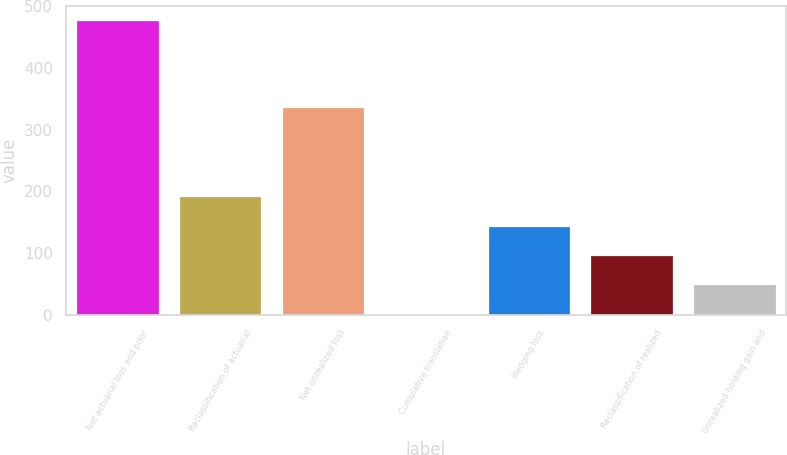Convert chart to OTSL. <chart><loc_0><loc_0><loc_500><loc_500><bar_chart><fcel>Net actuarial loss and prior<fcel>Reclassification of actuarial<fcel>Net unrealized loss<fcel>Cumulative translation<fcel>Hedging loss<fcel>Reclassification of realized<fcel>Unrealized holding gain and<nl><fcel>477<fcel>192<fcel>337<fcel>2<fcel>144.5<fcel>97<fcel>49.5<nl></chart> 